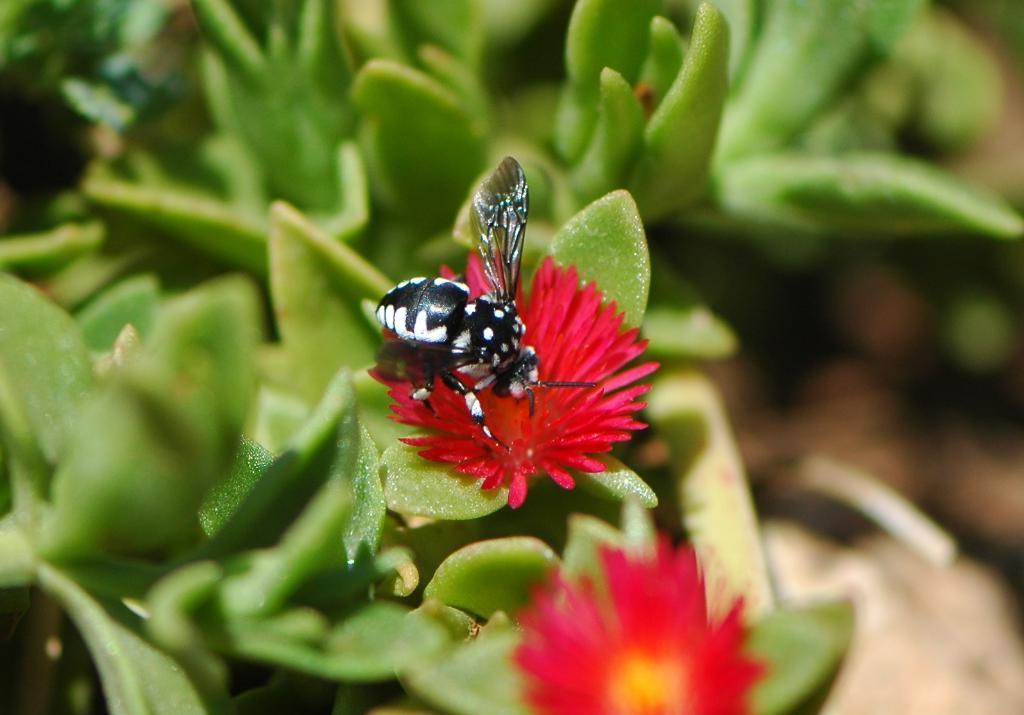Could you give a brief overview of what you see in this image? In this image we can see red color flowers and a insect is there on the flower. In the background of the image we can see leaves which are green in color, but it is in a blur. 